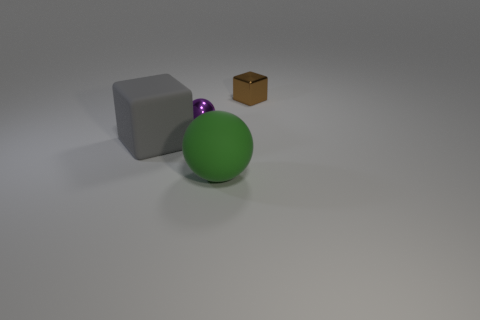There is a green matte ball right of the small purple object; is its size the same as the cube left of the green thing?
Offer a terse response. Yes. What number of objects are small shiny cylinders or cubes that are in front of the tiny brown metallic thing?
Offer a terse response. 1. Is there another gray matte thing that has the same shape as the big gray thing?
Give a very brief answer. No. How big is the cube that is left of the big thing that is to the right of the large gray thing?
Make the answer very short. Large. What number of metal objects are purple things or yellow cubes?
Offer a terse response. 1. How many purple matte balls are there?
Offer a terse response. 0. Is the ball behind the matte block made of the same material as the thing that is on the left side of the tiny purple metallic ball?
Offer a very short reply. No. What color is the other metal object that is the same shape as the large green object?
Keep it short and to the point. Purple. What material is the sphere to the right of the small thing in front of the tiny block?
Make the answer very short. Rubber. There is a big thing that is left of the large green matte thing; is it the same shape as the tiny object on the right side of the purple metallic thing?
Ensure brevity in your answer.  Yes. 